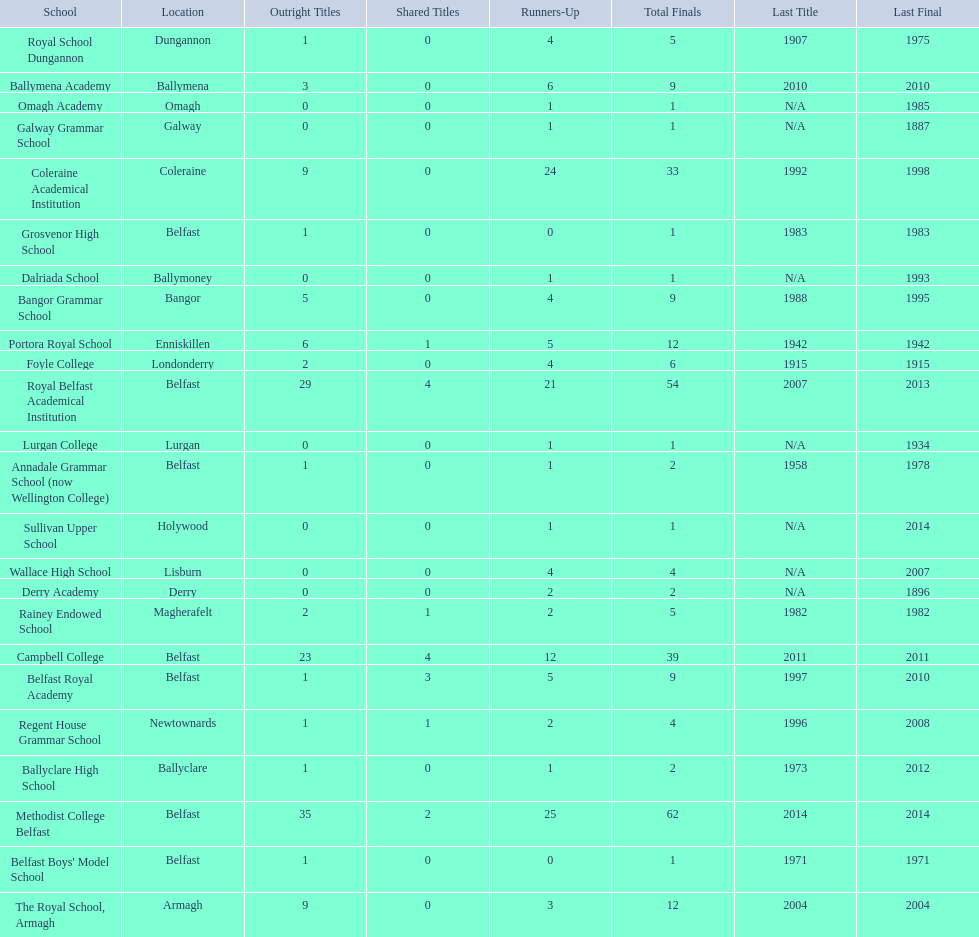How many schools have had at least 3 share titles? 3. I'm looking to parse the entire table for insights. Could you assist me with that? {'header': ['School', 'Location', 'Outright Titles', 'Shared Titles', 'Runners-Up', 'Total Finals', 'Last Title', 'Last Final'], 'rows': [['Royal School Dungannon', 'Dungannon', '1', '0', '4', '5', '1907', '1975'], ['Ballymena Academy', 'Ballymena', '3', '0', '6', '9', '2010', '2010'], ['Omagh Academy', 'Omagh', '0', '0', '1', '1', 'N/A', '1985'], ['Galway Grammar School', 'Galway', '0', '0', '1', '1', 'N/A', '1887'], ['Coleraine Academical Institution', 'Coleraine', '9', '0', '24', '33', '1992', '1998'], ['Grosvenor High School', 'Belfast', '1', '0', '0', '1', '1983', '1983'], ['Dalriada School', 'Ballymoney', '0', '0', '1', '1', 'N/A', '1993'], ['Bangor Grammar School', 'Bangor', '5', '0', '4', '9', '1988', '1995'], ['Portora Royal School', 'Enniskillen', '6', '1', '5', '12', '1942', '1942'], ['Foyle College', 'Londonderry', '2', '0', '4', '6', '1915', '1915'], ['Royal Belfast Academical Institution', 'Belfast', '29', '4', '21', '54', '2007', '2013'], ['Lurgan College', 'Lurgan', '0', '0', '1', '1', 'N/A', '1934'], ['Annadale Grammar School (now Wellington College)', 'Belfast', '1', '0', '1', '2', '1958', '1978'], ['Sullivan Upper School', 'Holywood', '0', '0', '1', '1', 'N/A', '2014'], ['Wallace High School', 'Lisburn', '0', '0', '4', '4', 'N/A', '2007'], ['Derry Academy', 'Derry', '0', '0', '2', '2', 'N/A', '1896'], ['Rainey Endowed School', 'Magherafelt', '2', '1', '2', '5', '1982', '1982'], ['Campbell College', 'Belfast', '23', '4', '12', '39', '2011', '2011'], ['Belfast Royal Academy', 'Belfast', '1', '3', '5', '9', '1997', '2010'], ['Regent House Grammar School', 'Newtownards', '1', '1', '2', '4', '1996', '2008'], ['Ballyclare High School', 'Ballyclare', '1', '0', '1', '2', '1973', '2012'], ['Methodist College Belfast', 'Belfast', '35', '2', '25', '62', '2014', '2014'], ["Belfast Boys' Model School", 'Belfast', '1', '0', '0', '1', '1971', '1971'], ['The Royal School, Armagh', 'Armagh', '9', '0', '3', '12', '2004', '2004']]} 